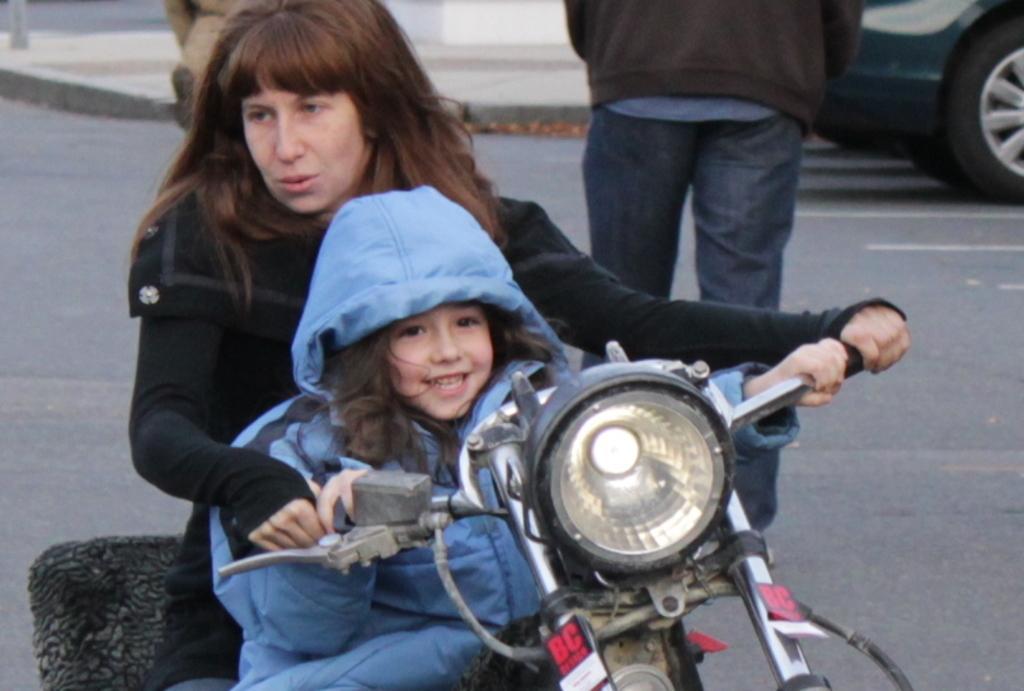In one or two sentences, can you explain what this image depicts? In the foreground of the image we can see two persons sitting on the motorcycle. One woman with long hair is wearing a black coat and a girl is wearing a blue coat. In the background, we can see two persons standing on the ground and a car is parked on the road. 